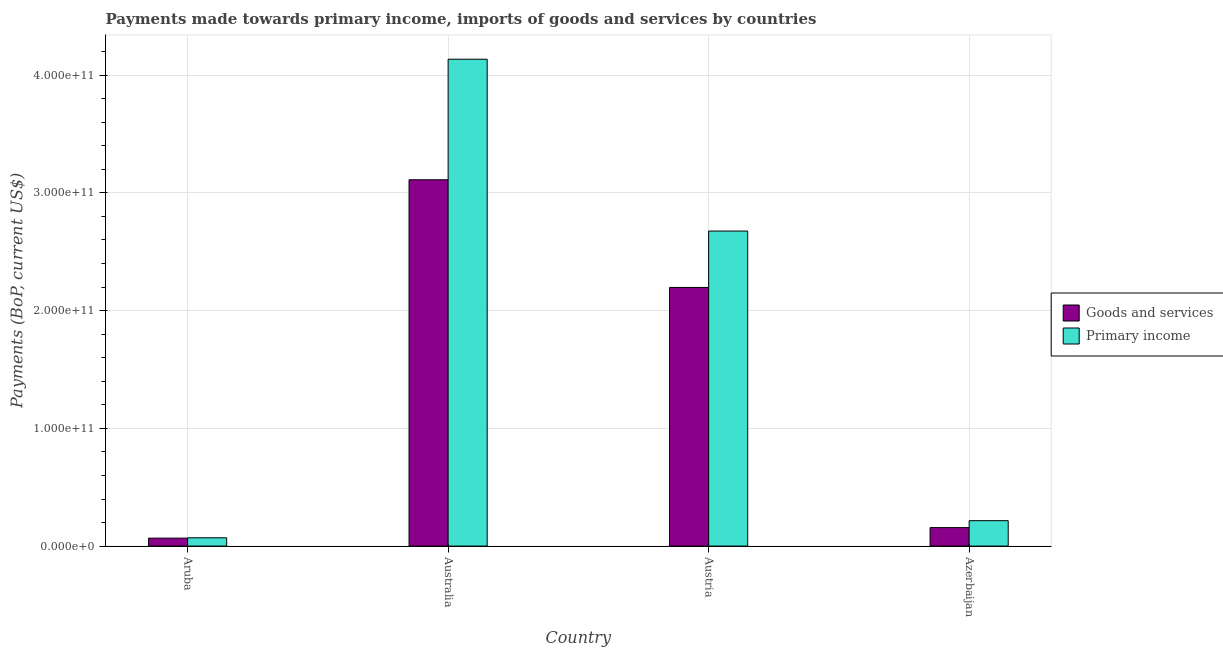How many different coloured bars are there?
Give a very brief answer. 2. How many groups of bars are there?
Make the answer very short. 4. Are the number of bars per tick equal to the number of legend labels?
Provide a succinct answer. Yes. How many bars are there on the 4th tick from the left?
Give a very brief answer. 2. In how many cases, is the number of bars for a given country not equal to the number of legend labels?
Give a very brief answer. 0. What is the payments made towards goods and services in Azerbaijan?
Ensure brevity in your answer.  1.57e+1. Across all countries, what is the maximum payments made towards primary income?
Offer a very short reply. 4.14e+11. Across all countries, what is the minimum payments made towards primary income?
Offer a terse response. 7.05e+09. In which country was the payments made towards primary income minimum?
Your answer should be very brief. Aruba. What is the total payments made towards primary income in the graph?
Keep it short and to the point. 7.10e+11. What is the difference between the payments made towards primary income in Australia and that in Austria?
Provide a short and direct response. 1.46e+11. What is the difference between the payments made towards primary income in Australia and the payments made towards goods and services in Aruba?
Provide a succinct answer. 4.07e+11. What is the average payments made towards primary income per country?
Provide a short and direct response. 1.77e+11. What is the difference between the payments made towards goods and services and payments made towards primary income in Aruba?
Provide a succinct answer. -2.86e+08. In how many countries, is the payments made towards primary income greater than 200000000000 US$?
Provide a succinct answer. 2. What is the ratio of the payments made towards goods and services in Austria to that in Azerbaijan?
Give a very brief answer. 13.99. What is the difference between the highest and the second highest payments made towards primary income?
Offer a terse response. 1.46e+11. What is the difference between the highest and the lowest payments made towards primary income?
Your answer should be compact. 4.06e+11. In how many countries, is the payments made towards primary income greater than the average payments made towards primary income taken over all countries?
Provide a short and direct response. 2. What does the 2nd bar from the left in Austria represents?
Offer a very short reply. Primary income. What does the 2nd bar from the right in Azerbaijan represents?
Give a very brief answer. Goods and services. How many bars are there?
Provide a short and direct response. 8. How many countries are there in the graph?
Ensure brevity in your answer.  4. What is the difference between two consecutive major ticks on the Y-axis?
Keep it short and to the point. 1.00e+11. Are the values on the major ticks of Y-axis written in scientific E-notation?
Ensure brevity in your answer.  Yes. Does the graph contain any zero values?
Make the answer very short. No. What is the title of the graph?
Provide a short and direct response. Payments made towards primary income, imports of goods and services by countries. Does "Taxes" appear as one of the legend labels in the graph?
Your response must be concise. No. What is the label or title of the X-axis?
Offer a terse response. Country. What is the label or title of the Y-axis?
Give a very brief answer. Payments (BoP, current US$). What is the Payments (BoP, current US$) in Goods and services in Aruba?
Give a very brief answer. 6.76e+09. What is the Payments (BoP, current US$) of Primary income in Aruba?
Provide a succinct answer. 7.05e+09. What is the Payments (BoP, current US$) in Goods and services in Australia?
Give a very brief answer. 3.11e+11. What is the Payments (BoP, current US$) in Primary income in Australia?
Keep it short and to the point. 4.14e+11. What is the Payments (BoP, current US$) in Goods and services in Austria?
Your answer should be compact. 2.20e+11. What is the Payments (BoP, current US$) in Primary income in Austria?
Your answer should be very brief. 2.68e+11. What is the Payments (BoP, current US$) of Goods and services in Azerbaijan?
Give a very brief answer. 1.57e+1. What is the Payments (BoP, current US$) of Primary income in Azerbaijan?
Keep it short and to the point. 2.16e+1. Across all countries, what is the maximum Payments (BoP, current US$) in Goods and services?
Offer a very short reply. 3.11e+11. Across all countries, what is the maximum Payments (BoP, current US$) of Primary income?
Provide a short and direct response. 4.14e+11. Across all countries, what is the minimum Payments (BoP, current US$) in Goods and services?
Offer a very short reply. 6.76e+09. Across all countries, what is the minimum Payments (BoP, current US$) in Primary income?
Your response must be concise. 7.05e+09. What is the total Payments (BoP, current US$) of Goods and services in the graph?
Keep it short and to the point. 5.53e+11. What is the total Payments (BoP, current US$) in Primary income in the graph?
Make the answer very short. 7.10e+11. What is the difference between the Payments (BoP, current US$) in Goods and services in Aruba and that in Australia?
Provide a succinct answer. -3.04e+11. What is the difference between the Payments (BoP, current US$) in Primary income in Aruba and that in Australia?
Keep it short and to the point. -4.06e+11. What is the difference between the Payments (BoP, current US$) of Goods and services in Aruba and that in Austria?
Make the answer very short. -2.13e+11. What is the difference between the Payments (BoP, current US$) of Primary income in Aruba and that in Austria?
Your answer should be very brief. -2.61e+11. What is the difference between the Payments (BoP, current US$) of Goods and services in Aruba and that in Azerbaijan?
Make the answer very short. -8.95e+09. What is the difference between the Payments (BoP, current US$) in Primary income in Aruba and that in Azerbaijan?
Your response must be concise. -1.45e+1. What is the difference between the Payments (BoP, current US$) of Goods and services in Australia and that in Austria?
Your answer should be very brief. 9.14e+1. What is the difference between the Payments (BoP, current US$) of Primary income in Australia and that in Austria?
Your answer should be very brief. 1.46e+11. What is the difference between the Payments (BoP, current US$) in Goods and services in Australia and that in Azerbaijan?
Your response must be concise. 2.95e+11. What is the difference between the Payments (BoP, current US$) in Primary income in Australia and that in Azerbaijan?
Your answer should be compact. 3.92e+11. What is the difference between the Payments (BoP, current US$) of Goods and services in Austria and that in Azerbaijan?
Offer a terse response. 2.04e+11. What is the difference between the Payments (BoP, current US$) in Primary income in Austria and that in Azerbaijan?
Ensure brevity in your answer.  2.46e+11. What is the difference between the Payments (BoP, current US$) in Goods and services in Aruba and the Payments (BoP, current US$) in Primary income in Australia?
Make the answer very short. -4.07e+11. What is the difference between the Payments (BoP, current US$) of Goods and services in Aruba and the Payments (BoP, current US$) of Primary income in Austria?
Your response must be concise. -2.61e+11. What is the difference between the Payments (BoP, current US$) in Goods and services in Aruba and the Payments (BoP, current US$) in Primary income in Azerbaijan?
Ensure brevity in your answer.  -1.48e+1. What is the difference between the Payments (BoP, current US$) of Goods and services in Australia and the Payments (BoP, current US$) of Primary income in Austria?
Ensure brevity in your answer.  4.35e+1. What is the difference between the Payments (BoP, current US$) of Goods and services in Australia and the Payments (BoP, current US$) of Primary income in Azerbaijan?
Offer a terse response. 2.90e+11. What is the difference between the Payments (BoP, current US$) in Goods and services in Austria and the Payments (BoP, current US$) in Primary income in Azerbaijan?
Your answer should be very brief. 1.98e+11. What is the average Payments (BoP, current US$) of Goods and services per country?
Offer a very short reply. 1.38e+11. What is the average Payments (BoP, current US$) of Primary income per country?
Give a very brief answer. 1.77e+11. What is the difference between the Payments (BoP, current US$) in Goods and services and Payments (BoP, current US$) in Primary income in Aruba?
Keep it short and to the point. -2.86e+08. What is the difference between the Payments (BoP, current US$) of Goods and services and Payments (BoP, current US$) of Primary income in Australia?
Offer a terse response. -1.02e+11. What is the difference between the Payments (BoP, current US$) of Goods and services and Payments (BoP, current US$) of Primary income in Austria?
Offer a terse response. -4.79e+1. What is the difference between the Payments (BoP, current US$) of Goods and services and Payments (BoP, current US$) of Primary income in Azerbaijan?
Ensure brevity in your answer.  -5.88e+09. What is the ratio of the Payments (BoP, current US$) of Goods and services in Aruba to that in Australia?
Provide a short and direct response. 0.02. What is the ratio of the Payments (BoP, current US$) of Primary income in Aruba to that in Australia?
Your response must be concise. 0.02. What is the ratio of the Payments (BoP, current US$) of Goods and services in Aruba to that in Austria?
Your response must be concise. 0.03. What is the ratio of the Payments (BoP, current US$) in Primary income in Aruba to that in Austria?
Ensure brevity in your answer.  0.03. What is the ratio of the Payments (BoP, current US$) in Goods and services in Aruba to that in Azerbaijan?
Give a very brief answer. 0.43. What is the ratio of the Payments (BoP, current US$) in Primary income in Aruba to that in Azerbaijan?
Keep it short and to the point. 0.33. What is the ratio of the Payments (BoP, current US$) of Goods and services in Australia to that in Austria?
Offer a very short reply. 1.42. What is the ratio of the Payments (BoP, current US$) in Primary income in Australia to that in Austria?
Make the answer very short. 1.55. What is the ratio of the Payments (BoP, current US$) in Goods and services in Australia to that in Azerbaijan?
Make the answer very short. 19.81. What is the ratio of the Payments (BoP, current US$) of Primary income in Australia to that in Azerbaijan?
Your answer should be very brief. 19.16. What is the ratio of the Payments (BoP, current US$) in Goods and services in Austria to that in Azerbaijan?
Provide a short and direct response. 13.99. What is the ratio of the Payments (BoP, current US$) in Primary income in Austria to that in Azerbaijan?
Keep it short and to the point. 12.4. What is the difference between the highest and the second highest Payments (BoP, current US$) of Goods and services?
Provide a succinct answer. 9.14e+1. What is the difference between the highest and the second highest Payments (BoP, current US$) in Primary income?
Offer a very short reply. 1.46e+11. What is the difference between the highest and the lowest Payments (BoP, current US$) in Goods and services?
Ensure brevity in your answer.  3.04e+11. What is the difference between the highest and the lowest Payments (BoP, current US$) of Primary income?
Provide a short and direct response. 4.06e+11. 